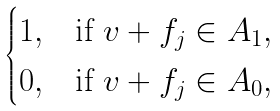Convert formula to latex. <formula><loc_0><loc_0><loc_500><loc_500>\begin{cases} 1 , & \text {if } v + f _ { j } \in A _ { 1 } , \\ 0 , & \text {if } v + f _ { j } \in A _ { 0 } , \end{cases}</formula> 